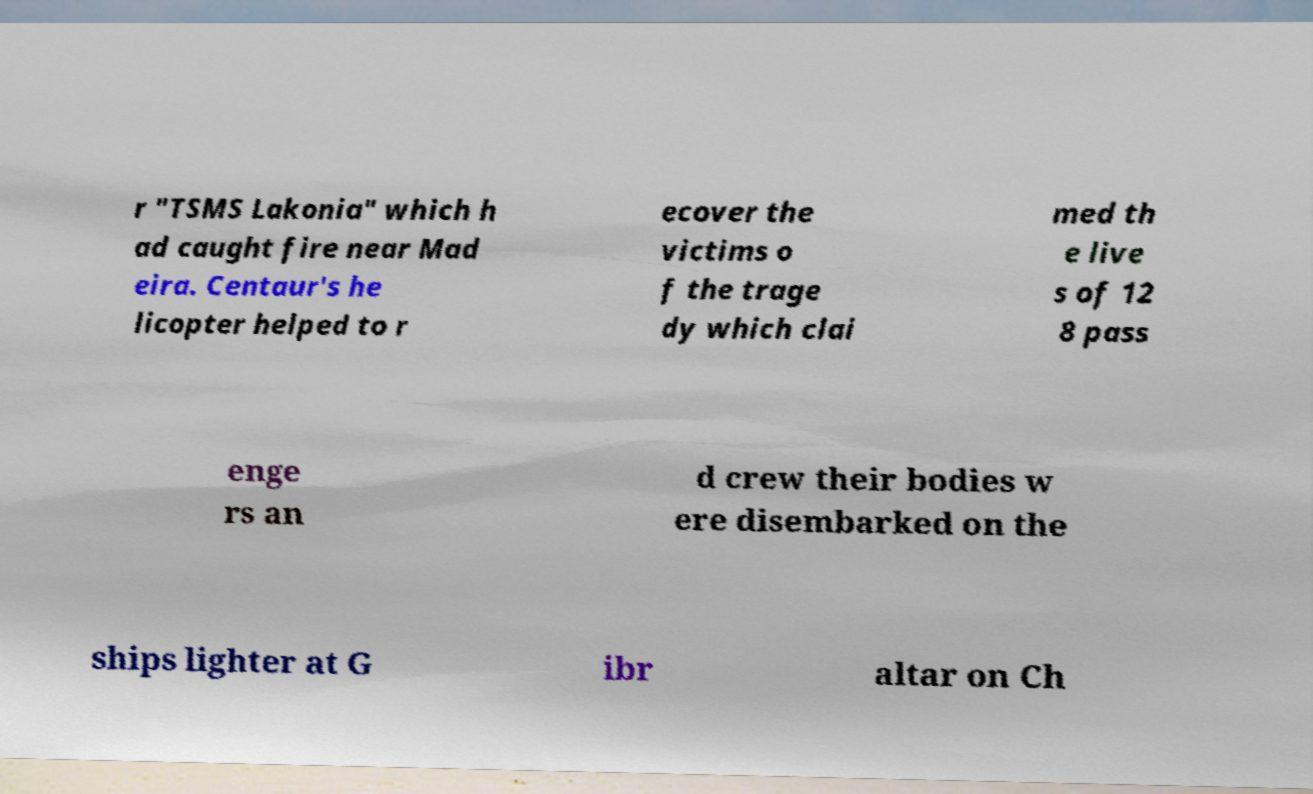Can you accurately transcribe the text from the provided image for me? r "TSMS Lakonia" which h ad caught fire near Mad eira. Centaur's he licopter helped to r ecover the victims o f the trage dy which clai med th e live s of 12 8 pass enge rs an d crew their bodies w ere disembarked on the ships lighter at G ibr altar on Ch 